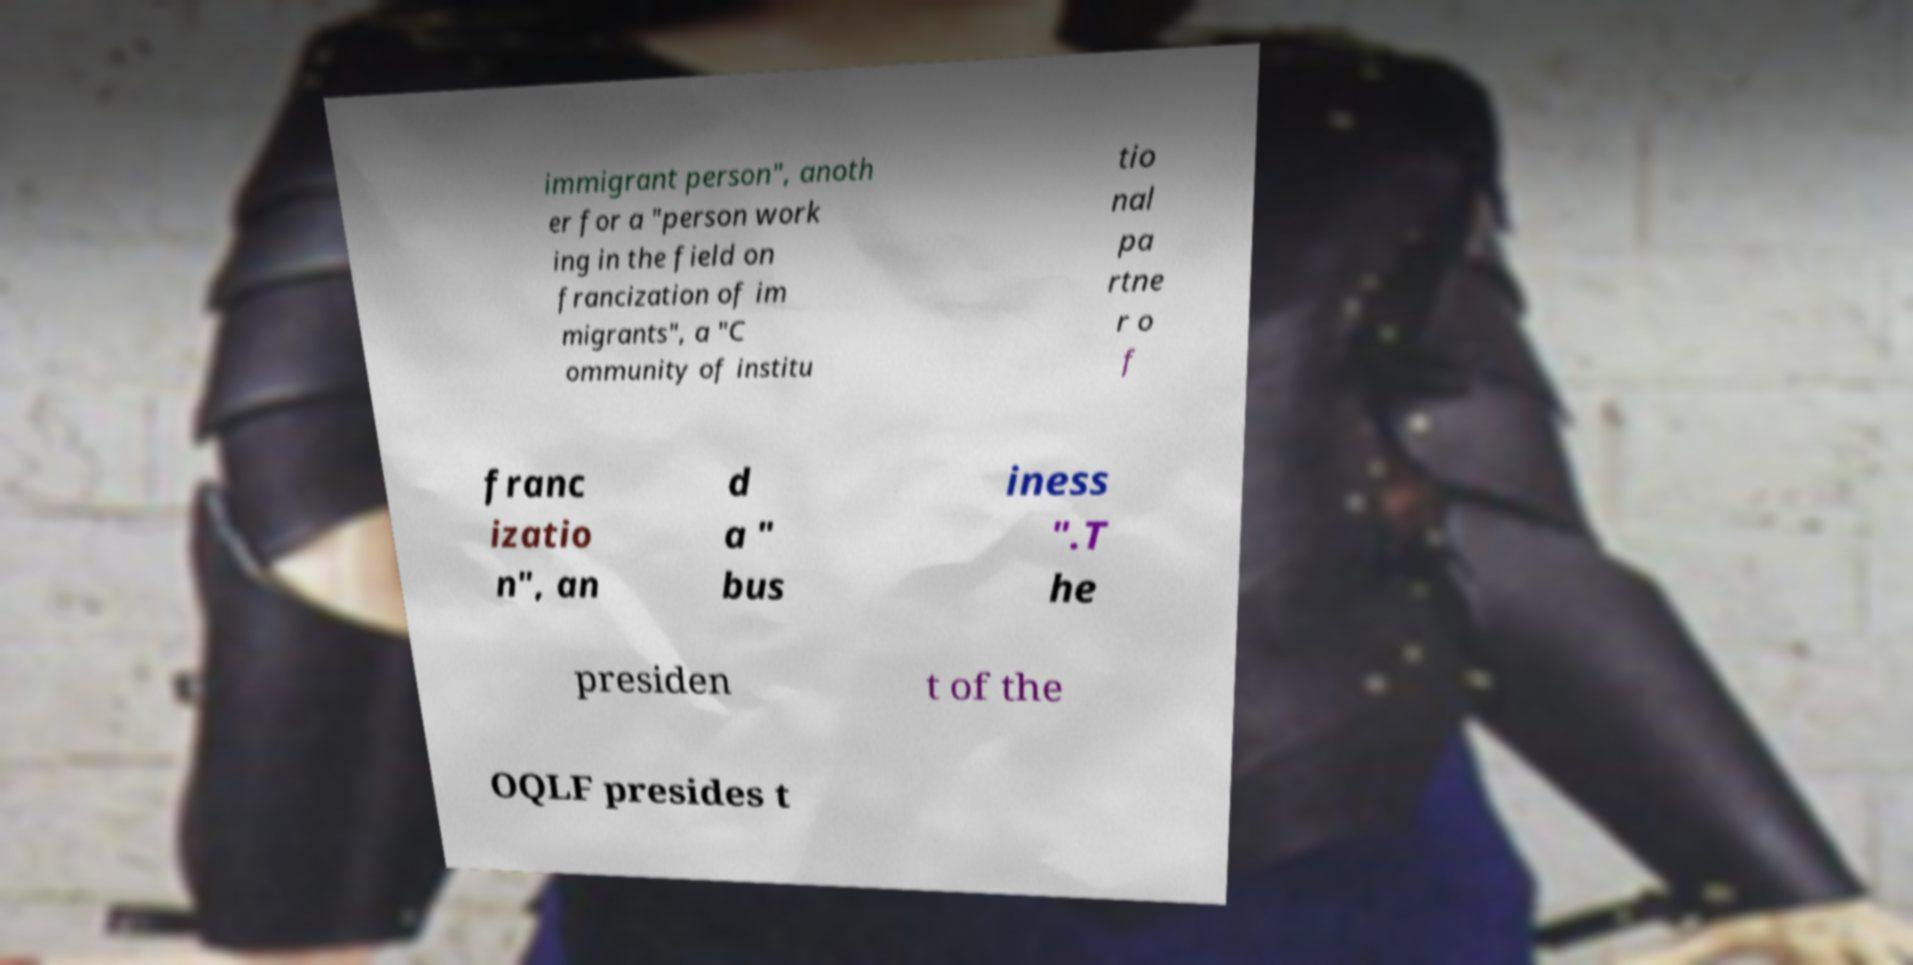Could you assist in decoding the text presented in this image and type it out clearly? immigrant person", anoth er for a "person work ing in the field on francization of im migrants", a "C ommunity of institu tio nal pa rtne r o f franc izatio n", an d a " bus iness ".T he presiden t of the OQLF presides t 